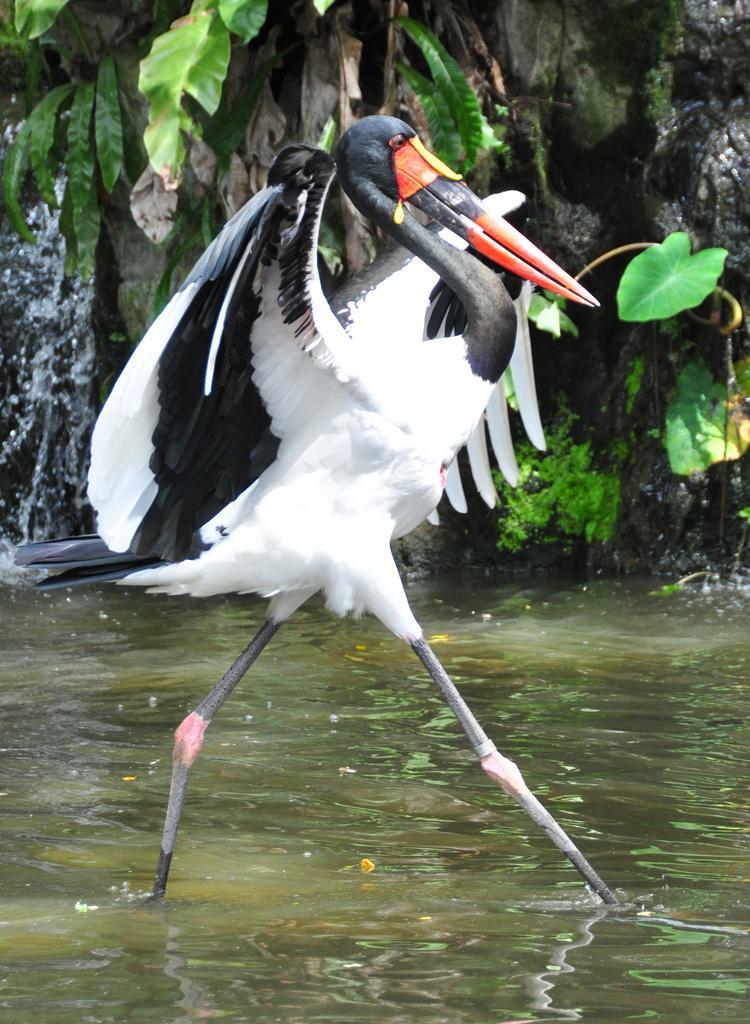How would you summarize this image in a sentence or two? In the image there is a white and black color flamingo walking in the water and in the back there is a tree. 